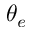<formula> <loc_0><loc_0><loc_500><loc_500>\theta _ { e }</formula> 